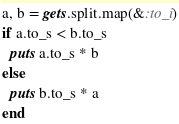<code> <loc_0><loc_0><loc_500><loc_500><_Ruby_>a, b = gets.split.map(&:to_i)
if a.to_s < b.to_s
  puts a.to_s * b
else
  puts b.to_s * a
end
</code> 